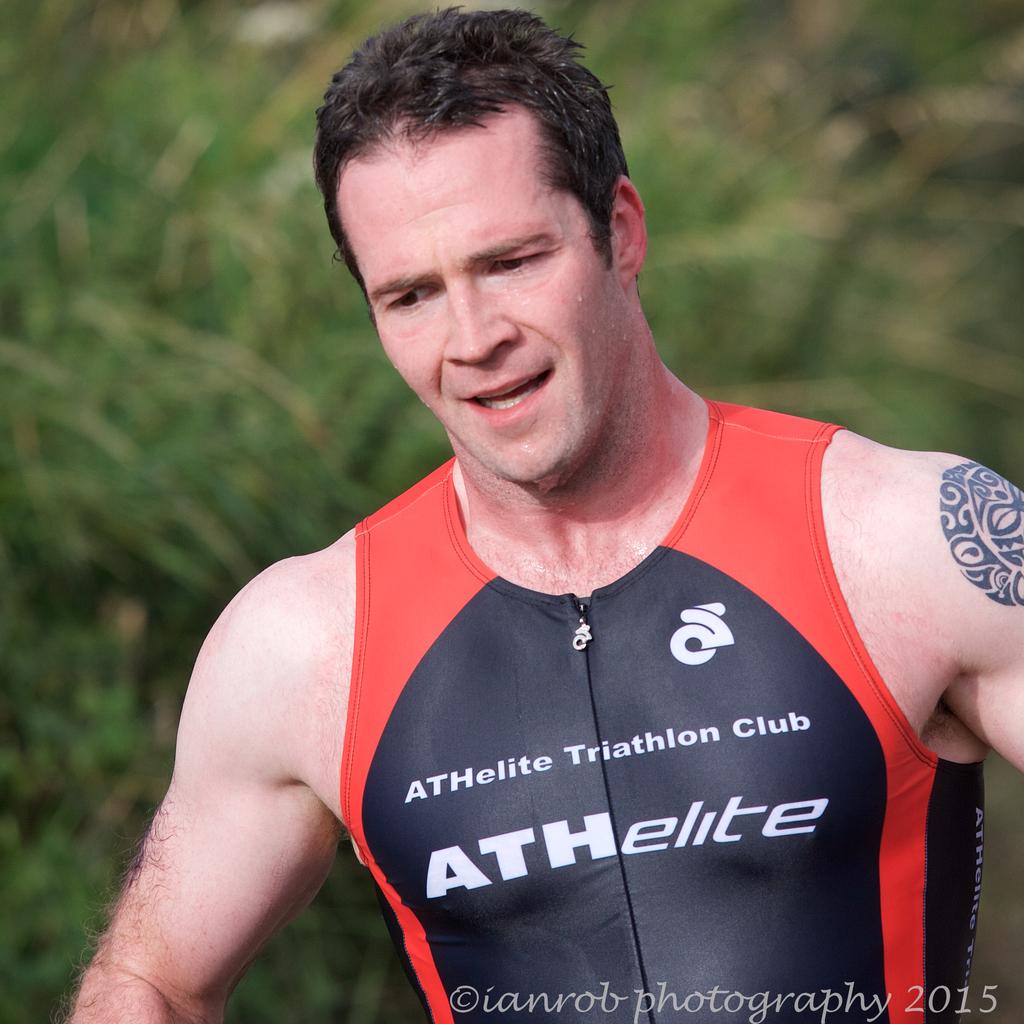What kind of club does the man belong to?
Make the answer very short. Triathlon. What kind of marathon is this?
Offer a terse response. Triathlon. 